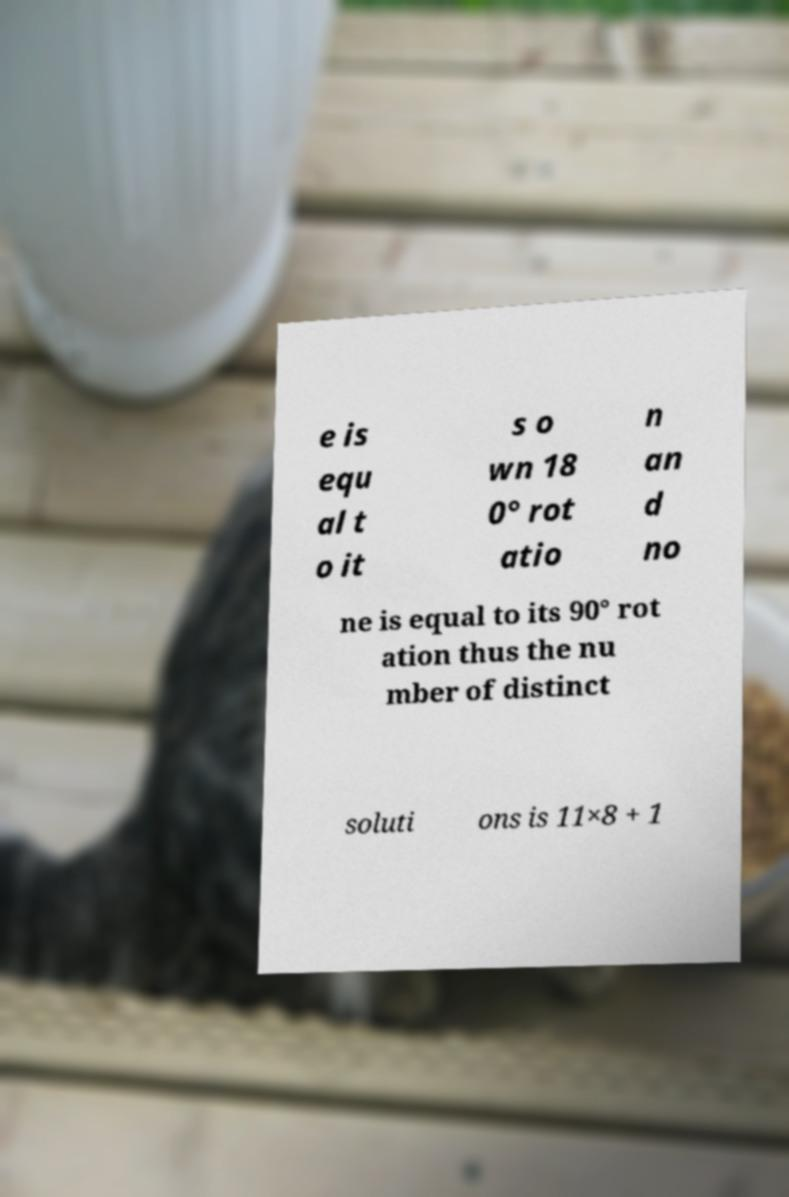I need the written content from this picture converted into text. Can you do that? e is equ al t o it s o wn 18 0° rot atio n an d no ne is equal to its 90° rot ation thus the nu mber of distinct soluti ons is 11×8 + 1 